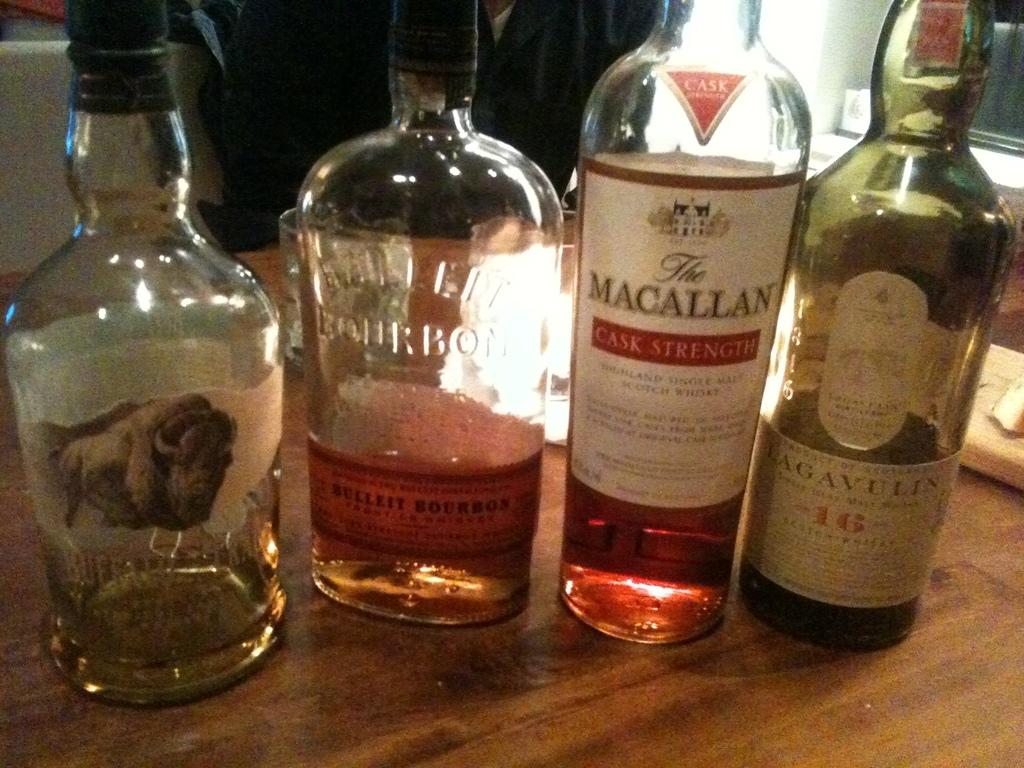What is the brand on the second to right bottle?
Give a very brief answer. The macallan. What number is on the bottle closest to the right?
Offer a very short reply. 16. 